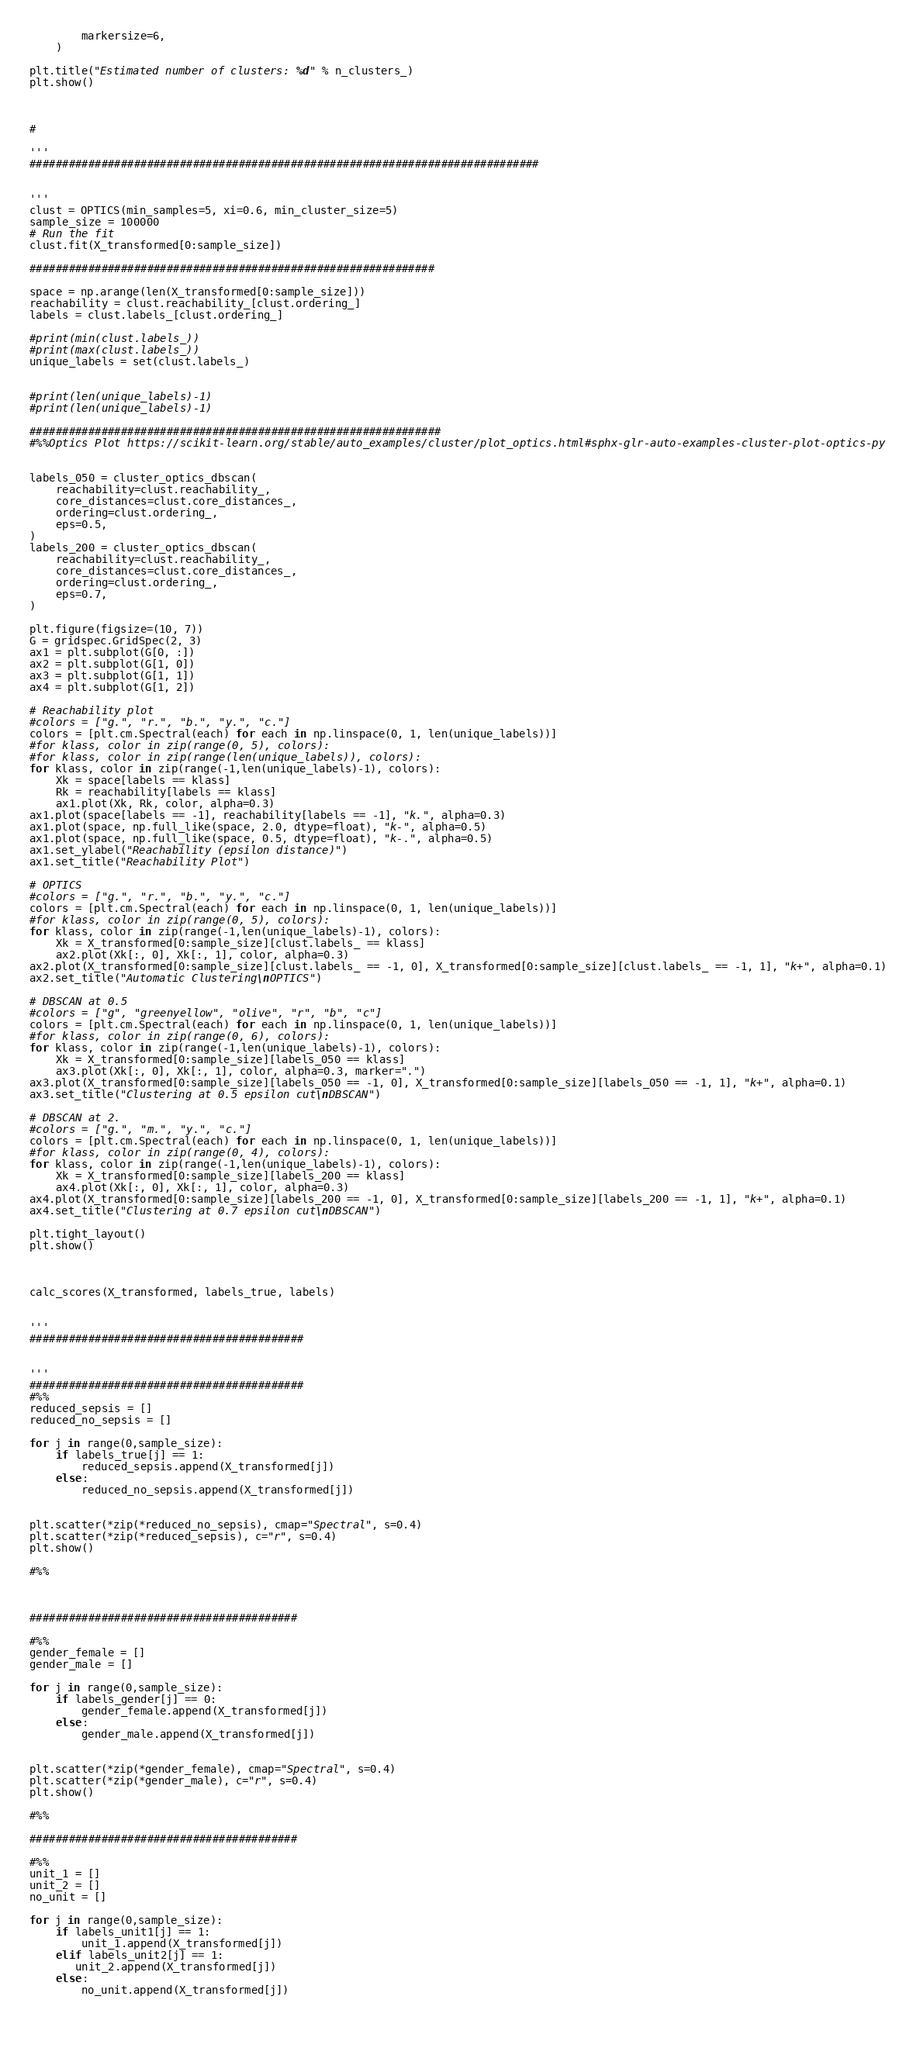<code> <loc_0><loc_0><loc_500><loc_500><_Python_>        markersize=6,
    )

plt.title("Estimated number of clusters: %d" % n_clusters_)
plt.show()



#

'''
##############################################################################


'''
clust = OPTICS(min_samples=5, xi=0.6, min_cluster_size=5)
sample_size = 100000
# Run the fit
clust.fit(X_transformed[0:sample_size])

##############################################################

space = np.arange(len(X_transformed[0:sample_size]))
reachability = clust.reachability_[clust.ordering_]
labels = clust.labels_[clust.ordering_]

#print(min(clust.labels_))
#print(max(clust.labels_))
unique_labels = set(clust.labels_)


#print(len(unique_labels)-1)
#print(len(unique_labels)-1)

###############################################################
#%%Optics Plot https://scikit-learn.org/stable/auto_examples/cluster/plot_optics.html#sphx-glr-auto-examples-cluster-plot-optics-py


labels_050 = cluster_optics_dbscan(
    reachability=clust.reachability_,
    core_distances=clust.core_distances_,
    ordering=clust.ordering_,
    eps=0.5,
)
labels_200 = cluster_optics_dbscan(
    reachability=clust.reachability_,
    core_distances=clust.core_distances_,
    ordering=clust.ordering_,
    eps=0.7,
)

plt.figure(figsize=(10, 7))
G = gridspec.GridSpec(2, 3)
ax1 = plt.subplot(G[0, :])
ax2 = plt.subplot(G[1, 0])
ax3 = plt.subplot(G[1, 1])
ax4 = plt.subplot(G[1, 2])

# Reachability plot
#colors = ["g.", "r.", "b.", "y.", "c."]
colors = [plt.cm.Spectral(each) for each in np.linspace(0, 1, len(unique_labels))]
#for klass, color in zip(range(0, 5), colors):
#for klass, color in zip(range(len(unique_labels)), colors):
for klass, color in zip(range(-1,len(unique_labels)-1), colors):
    Xk = space[labels == klass]
    Rk = reachability[labels == klass]
    ax1.plot(Xk, Rk, color, alpha=0.3)
ax1.plot(space[labels == -1], reachability[labels == -1], "k.", alpha=0.3)
ax1.plot(space, np.full_like(space, 2.0, dtype=float), "k-", alpha=0.5)
ax1.plot(space, np.full_like(space, 0.5, dtype=float), "k-.", alpha=0.5)
ax1.set_ylabel("Reachability (epsilon distance)")
ax1.set_title("Reachability Plot")

# OPTICS
#colors = ["g.", "r.", "b.", "y.", "c."]
colors = [plt.cm.Spectral(each) for each in np.linspace(0, 1, len(unique_labels))]
#for klass, color in zip(range(0, 5), colors):
for klass, color in zip(range(-1,len(unique_labels)-1), colors):
    Xk = X_transformed[0:sample_size][clust.labels_ == klass]
    ax2.plot(Xk[:, 0], Xk[:, 1], color, alpha=0.3)
ax2.plot(X_transformed[0:sample_size][clust.labels_ == -1, 0], X_transformed[0:sample_size][clust.labels_ == -1, 1], "k+", alpha=0.1)
ax2.set_title("Automatic Clustering\nOPTICS")

# DBSCAN at 0.5
#colors = ["g", "greenyellow", "olive", "r", "b", "c"]
colors = [plt.cm.Spectral(each) for each in np.linspace(0, 1, len(unique_labels))]
#for klass, color in zip(range(0, 6), colors):
for klass, color in zip(range(-1,len(unique_labels)-1), colors):
    Xk = X_transformed[0:sample_size][labels_050 == klass]
    ax3.plot(Xk[:, 0], Xk[:, 1], color, alpha=0.3, marker=".")
ax3.plot(X_transformed[0:sample_size][labels_050 == -1, 0], X_transformed[0:sample_size][labels_050 == -1, 1], "k+", alpha=0.1)
ax3.set_title("Clustering at 0.5 epsilon cut\nDBSCAN")

# DBSCAN at 2.
#colors = ["g.", "m.", "y.", "c."]
colors = [plt.cm.Spectral(each) for each in np.linspace(0, 1, len(unique_labels))]
#for klass, color in zip(range(0, 4), colors):
for klass, color in zip(range(-1,len(unique_labels)-1), colors):
    Xk = X_transformed[0:sample_size][labels_200 == klass]
    ax4.plot(Xk[:, 0], Xk[:, 1], color, alpha=0.3)
ax4.plot(X_transformed[0:sample_size][labels_200 == -1, 0], X_transformed[0:sample_size][labels_200 == -1, 1], "k+", alpha=0.1)
ax4.set_title("Clustering at 0.7 epsilon cut\nDBSCAN")

plt.tight_layout()
plt.show()



calc_scores(X_transformed, labels_true, labels)


'''
##########################################


'''
##########################################
#%%
reduced_sepsis = []
reduced_no_sepsis = []

for j in range(0,sample_size):
    if labels_true[j] == 1:
        reduced_sepsis.append(X_transformed[j])
    else:
        reduced_no_sepsis.append(X_transformed[j])

       
plt.scatter(*zip(*reduced_no_sepsis), cmap="Spectral", s=0.4)
plt.scatter(*zip(*reduced_sepsis), c="r", s=0.4)
plt.show()

#%% 



#########################################

#%%
gender_female = []
gender_male = []

for j in range(0,sample_size):
    if labels_gender[j] == 0:
        gender_female.append(X_transformed[j])
    else:
        gender_male.append(X_transformed[j])

       
plt.scatter(*zip(*gender_female), cmap="Spectral", s=0.4)
plt.scatter(*zip(*gender_male), c="r", s=0.4)
plt.show()

#%% 

#########################################

#%%
unit_1 = []
unit_2 = []
no_unit = []

for j in range(0,sample_size):
    if labels_unit1[j] == 1:
        unit_1.append(X_transformed[j])
    elif labels_unit2[j] == 1:
       unit_2.append(X_transformed[j])
    else:
        no_unit.append(X_transformed[j])

       </code> 